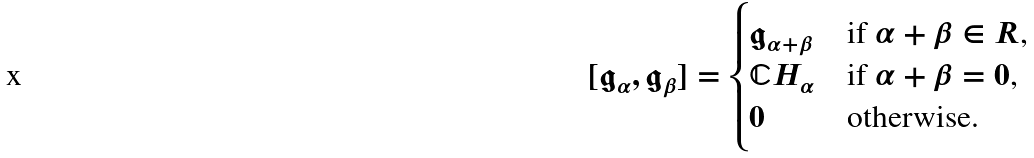<formula> <loc_0><loc_0><loc_500><loc_500>[ \mathfrak g _ { \alpha } , \mathfrak g _ { \beta } ] = \begin{cases} \mathfrak g _ { \alpha + \beta } & \text {if $\alpha+\beta \in R$,} \\ \mathbb { C } H _ { \alpha } & \text {if $\alpha+\beta =0$,} \\ 0 & \text {otherwise.} \end{cases}</formula> 